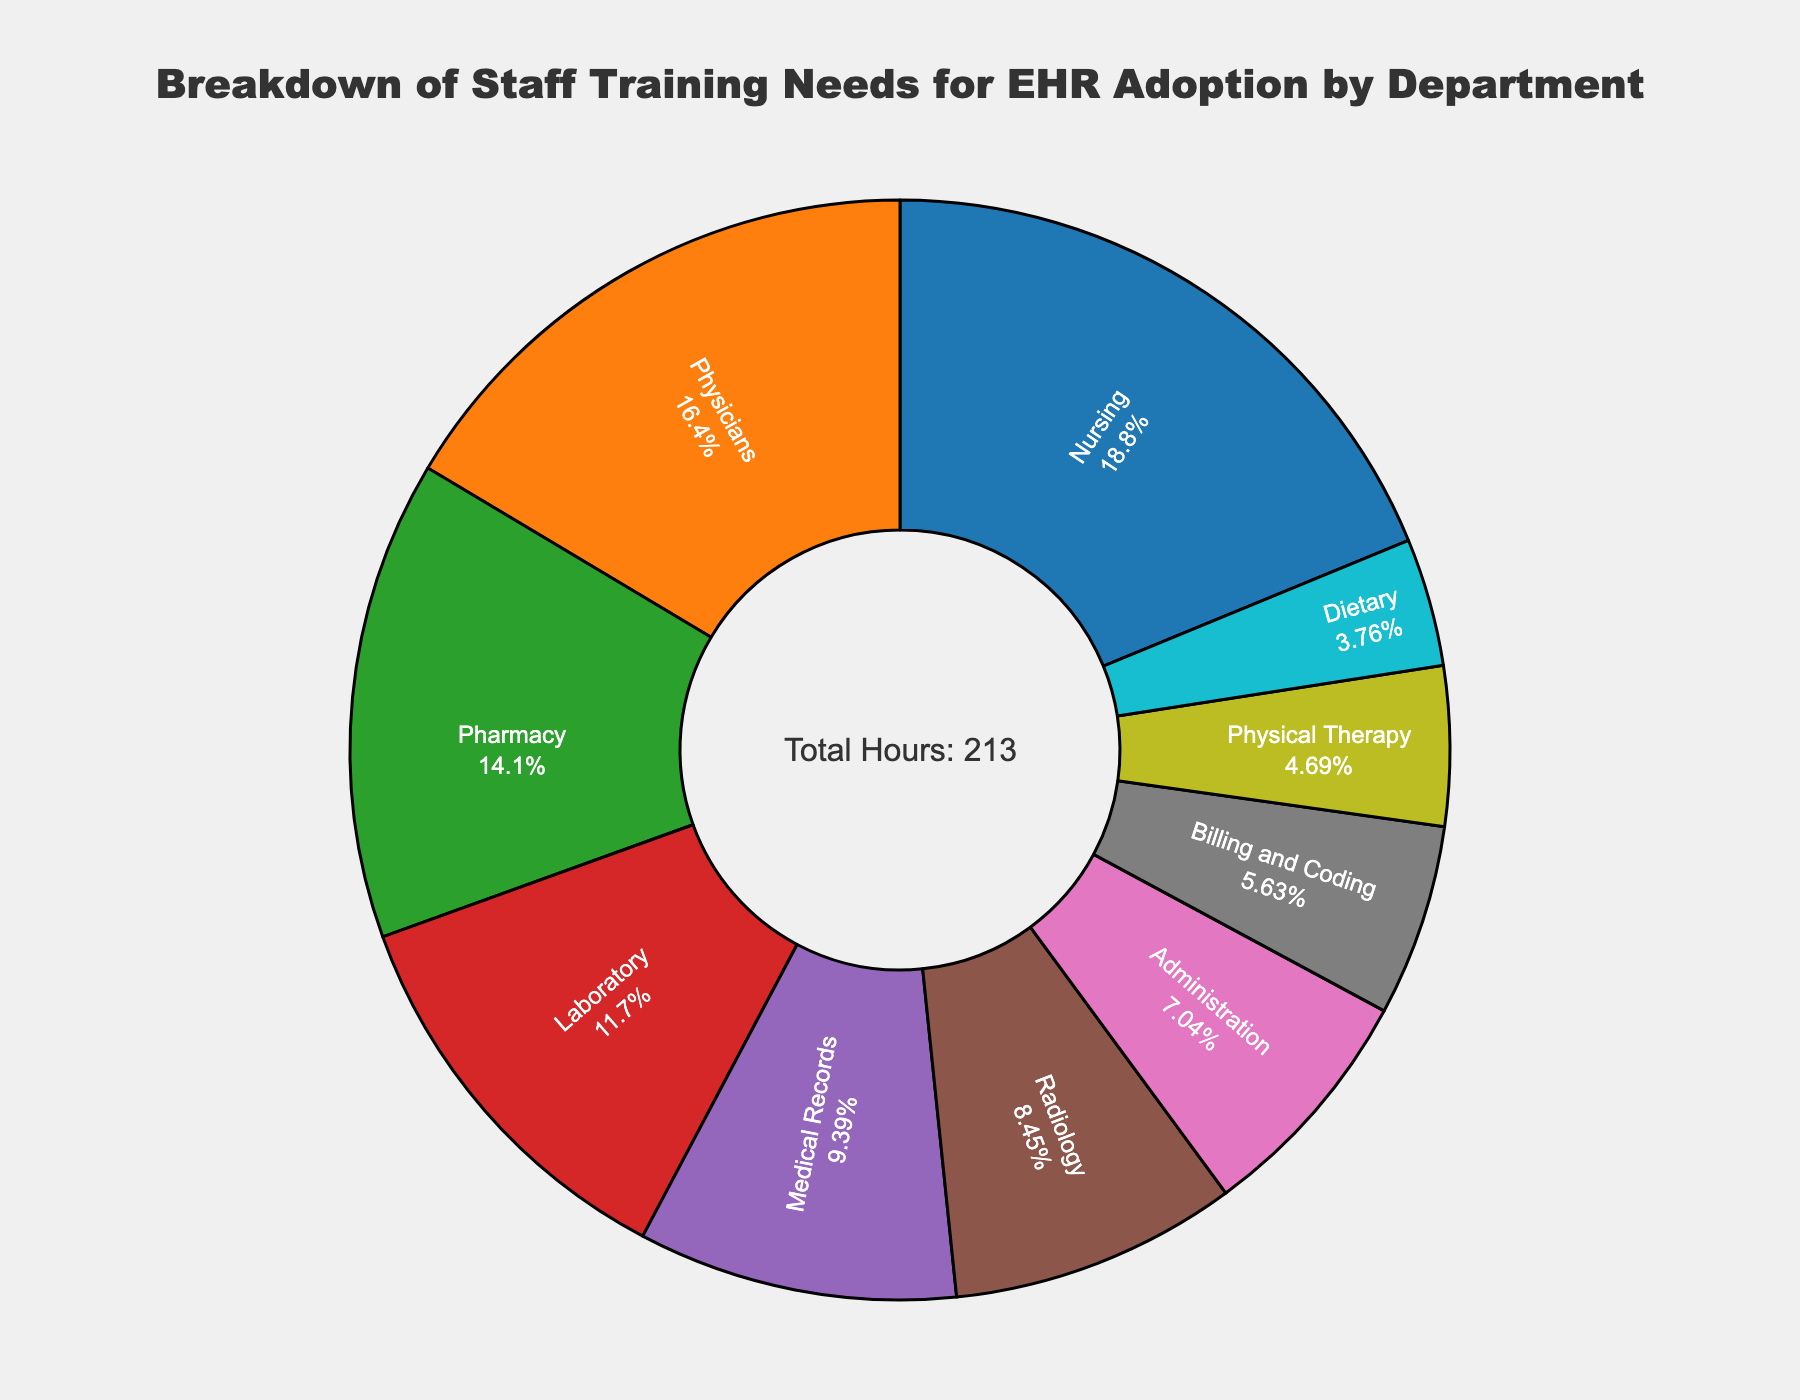Which department requires the most training hours? By looking at the pie chart, find the largest segment. The largest segment represents the department that requires the most training hours.
Answer: Nursing What percentage of the total training hours is dedicated to the Physicians department? Identify the segment for Physicians, and refer to the percentage shown inside that segment in the pie chart.
Answer: 20% How many more training hours does the Nursing department need compared to the Radiology department? Subtract the training hours for Radiology (18) from the training hours for Nursing (40). 40 - 18 = 22
Answer: 22 hours Which departments combined take up more than 50% of the total training hours? Identify the segments contributing the highest percentages until the combined total exceeds 50%. Nursing (23.5%) + Physicians (20.6%) = 44.1%, add Pharmacy (17.6%) for a combined total of 61.7%.
Answer: Nursing, Physicians, Pharmacy What are the three departments with the least amount of training required? Identify the three smallest segments in the pie chart. These correspond to the departments with the least training hours.
Answer: Dietary, Physical Therapy, Billing and Coding How many total training hours are required for the Administration, Billing and Coding, and Dietary departments combined? Sum the training hours for these departments: Administration (15) + Billing and Coding (12) + Dietary (8). 15 + 12 + 8 = 35 hours
Answer: 35 hours Does the combined training hours for Laboratory and Medical Records departments exceed that of the Pharmacy department? Add the training hours for Laboratory (25) and Medical Records (20) to get a combined total of 45 hours. Compare this with the 30 hours required by the Pharmacy department (45 > 30).
Answer: Yes How does the training need for the Physical Therapy department compare to the average training hours per department? Calculate the average training hours per department: (40 + 35 + 30 + 25 + 20 + 18 + 15 + 12 + 10 + 8) / 10 = 233 / 10 = 23.3 hours. Compare Physical Therapy’s 10 hours to this average (10 < 23.3).
Answer: Below average What is the total number of training hours required across all departments? Sum the training hours for all departments: (40 + 35 + 30 + 25 + 20 + 18 + 15 + 12 + 10 + 8) = 233 hours.
Answer: 233 hours Which department has a segment colored blue in the pie chart? Look at the pie chart and identify the department that corresponds to the blue segment.
Answer: Nursing 